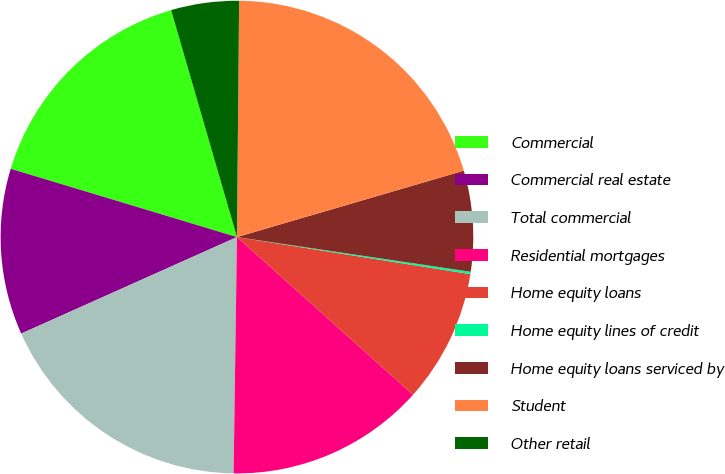Convert chart to OTSL. <chart><loc_0><loc_0><loc_500><loc_500><pie_chart><fcel>Commercial<fcel>Commercial real estate<fcel>Total commercial<fcel>Residential mortgages<fcel>Home equity loans<fcel>Home equity lines of credit<fcel>Home equity loans serviced by<fcel>Student<fcel>Other retail<nl><fcel>15.84%<fcel>11.36%<fcel>18.08%<fcel>13.6%<fcel>9.12%<fcel>0.16%<fcel>6.88%<fcel>20.32%<fcel>4.64%<nl></chart> 